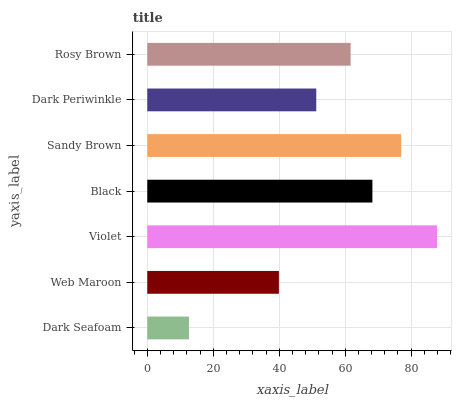Is Dark Seafoam the minimum?
Answer yes or no. Yes. Is Violet the maximum?
Answer yes or no. Yes. Is Web Maroon the minimum?
Answer yes or no. No. Is Web Maroon the maximum?
Answer yes or no. No. Is Web Maroon greater than Dark Seafoam?
Answer yes or no. Yes. Is Dark Seafoam less than Web Maroon?
Answer yes or no. Yes. Is Dark Seafoam greater than Web Maroon?
Answer yes or no. No. Is Web Maroon less than Dark Seafoam?
Answer yes or no. No. Is Rosy Brown the high median?
Answer yes or no. Yes. Is Rosy Brown the low median?
Answer yes or no. Yes. Is Dark Periwinkle the high median?
Answer yes or no. No. Is Web Maroon the low median?
Answer yes or no. No. 